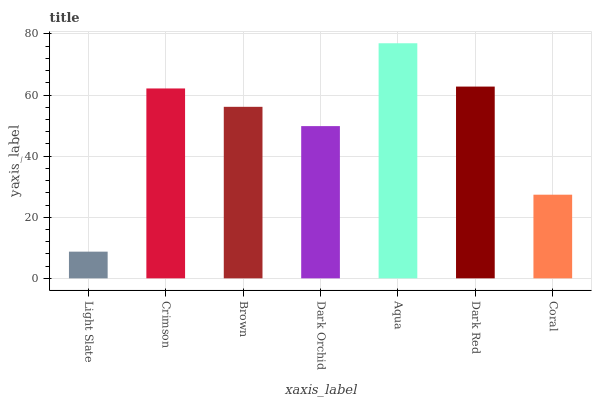Is Crimson the minimum?
Answer yes or no. No. Is Crimson the maximum?
Answer yes or no. No. Is Crimson greater than Light Slate?
Answer yes or no. Yes. Is Light Slate less than Crimson?
Answer yes or no. Yes. Is Light Slate greater than Crimson?
Answer yes or no. No. Is Crimson less than Light Slate?
Answer yes or no. No. Is Brown the high median?
Answer yes or no. Yes. Is Brown the low median?
Answer yes or no. Yes. Is Aqua the high median?
Answer yes or no. No. Is Dark Orchid the low median?
Answer yes or no. No. 